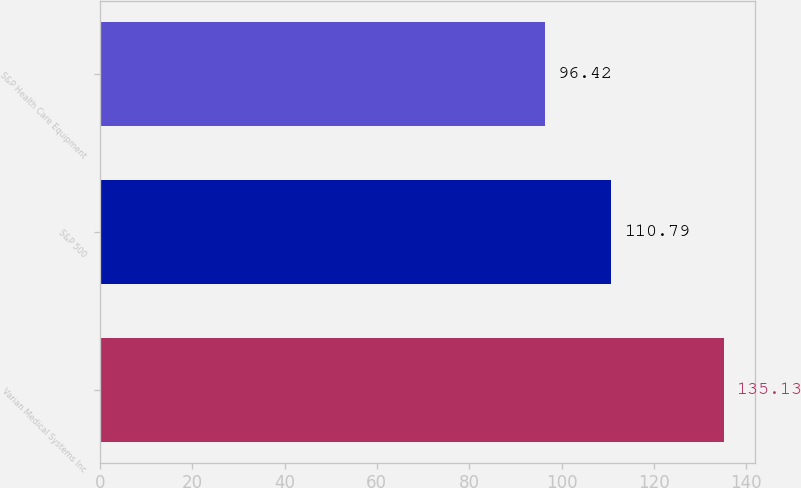<chart> <loc_0><loc_0><loc_500><loc_500><bar_chart><fcel>Varian Medical Systems Inc<fcel>S&P 500<fcel>S&P Health Care Equipment<nl><fcel>135.13<fcel>110.79<fcel>96.42<nl></chart> 